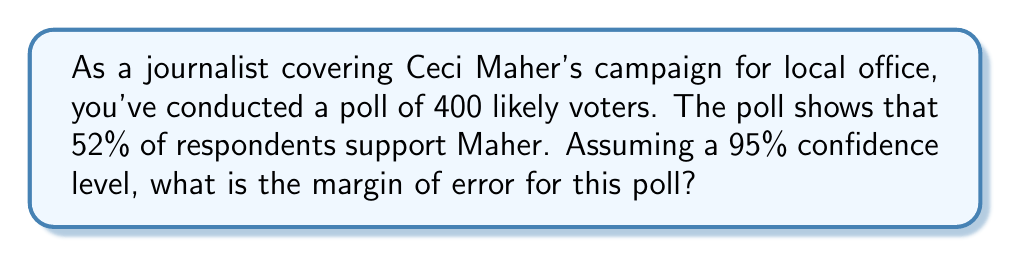Could you help me with this problem? To calculate the margin of error for this poll, we'll use the formula:

$$ \text{Margin of Error} = z \sqrt{\frac{p(1-p)}{n}} $$

Where:
$z$ = z-score (1.96 for 95% confidence level)
$p$ = sample proportion (0.52 in this case)
$n$ = sample size (400)

Step 1: Determine the z-score for 95% confidence level
$z = 1.96$

Step 2: Calculate $p(1-p)$
$p(1-p) = 0.52(1-0.52) = 0.52 \times 0.48 = 0.2496$

Step 3: Divide $p(1-p)$ by $n$
$\frac{p(1-p)}{n} = \frac{0.2496}{400} = 0.000624$

Step 4: Take the square root
$\sqrt{0.000624} = 0.024979$

Step 5: Multiply by z-score
$1.96 \times 0.024979 = 0.048959$

Step 6: Convert to percentage
$0.048959 \times 100 = 4.8959\%$

Therefore, the margin of error is approximately 4.90%.
Answer: 4.90% 